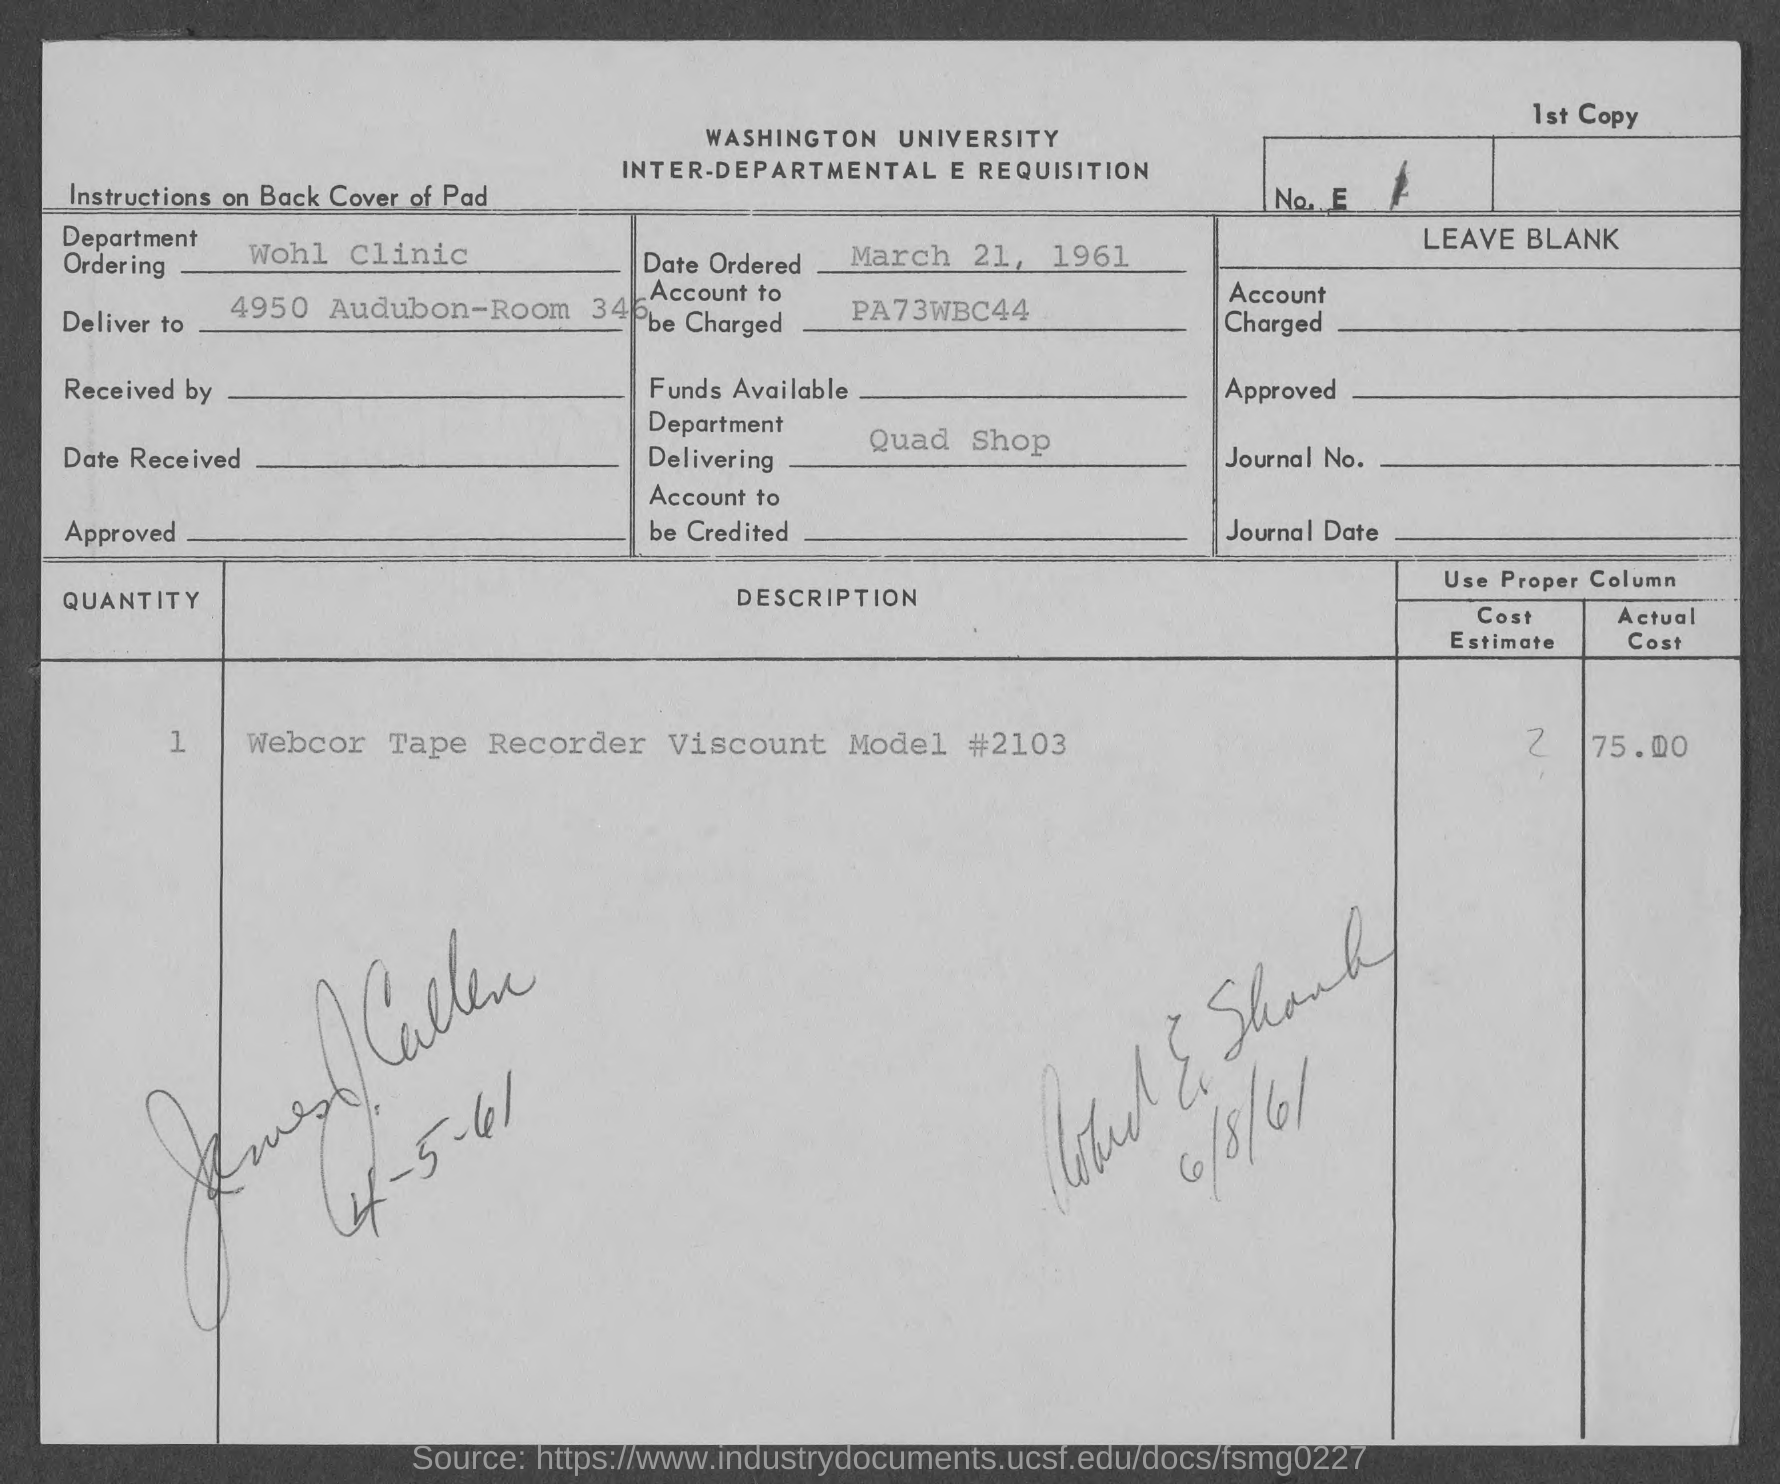Mention a couple of crucial points in this snapshot. On March 21, 1961, the order was placed. The name of the department mentioned in the given page is Quad Shop. The account to be charged, as specified on the given page, is PA73WBC44... The name of the department ordering as mentioned on the given page is Wohl Clinic. The quantity mentioned on page 1 is 1. 